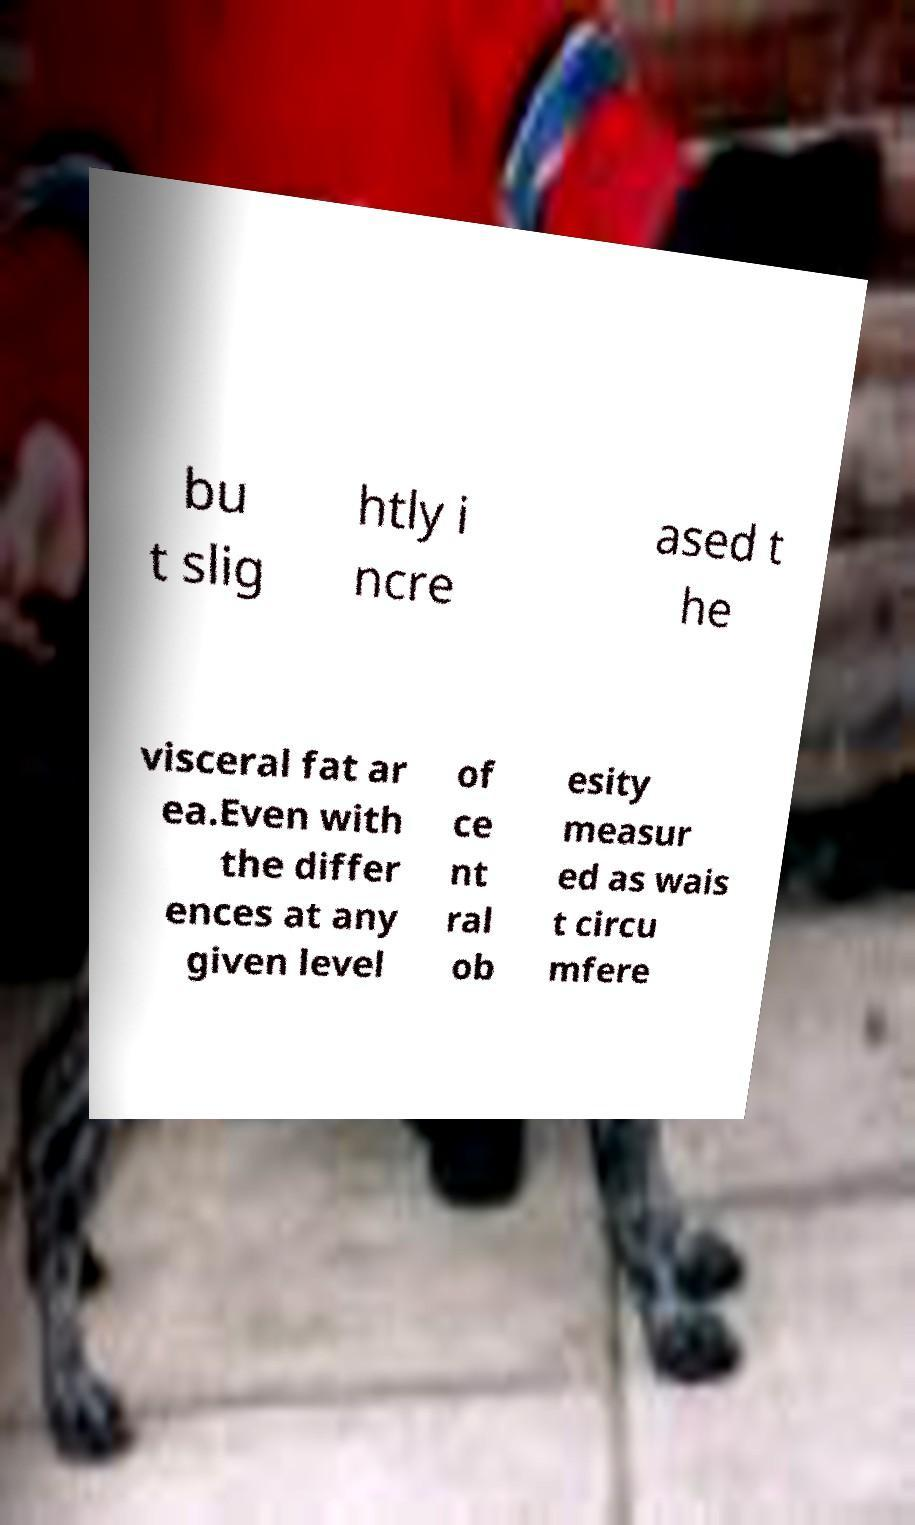What messages or text are displayed in this image? I need them in a readable, typed format. bu t slig htly i ncre ased t he visceral fat ar ea.Even with the differ ences at any given level of ce nt ral ob esity measur ed as wais t circu mfere 